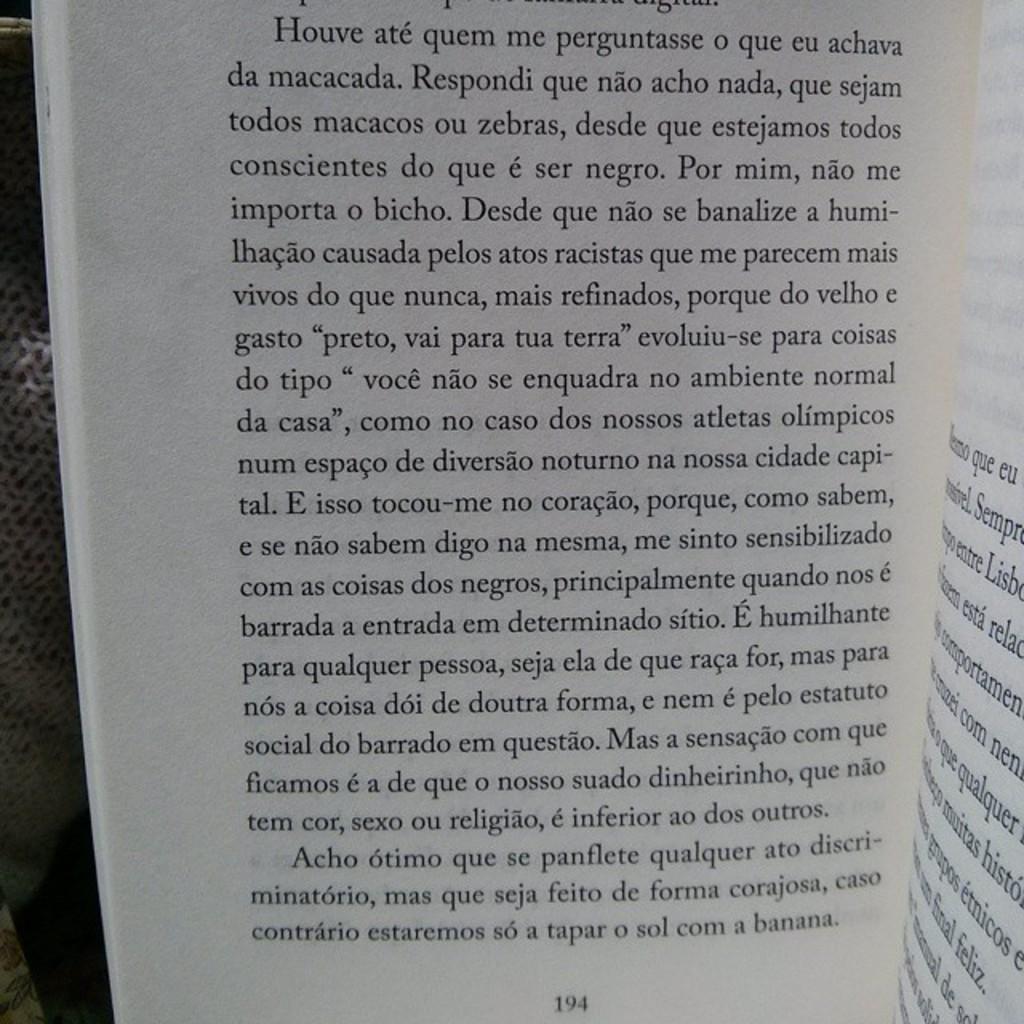What page is the book open to?
Your answer should be compact. 194. What is the last letter of the last word on the page?
Keep it short and to the point. A. 